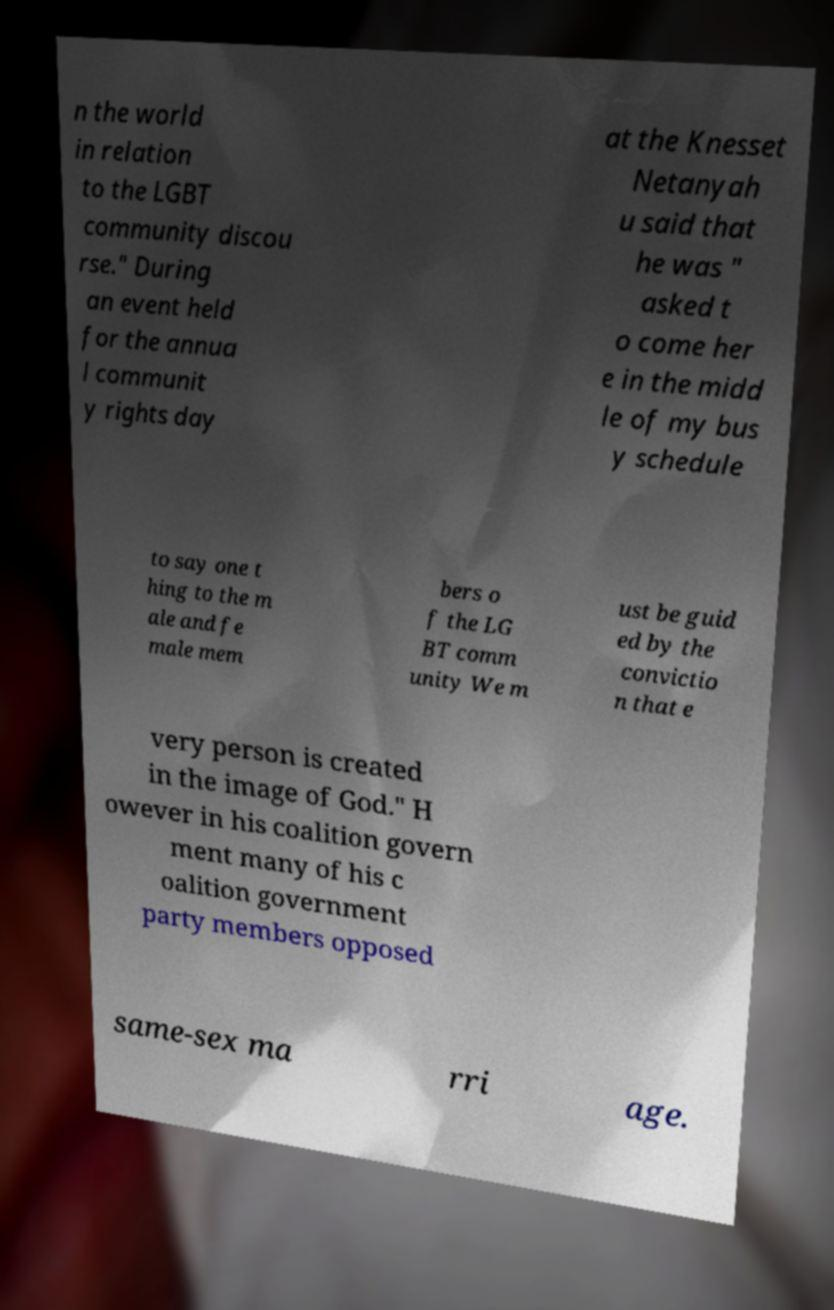Can you accurately transcribe the text from the provided image for me? n the world in relation to the LGBT community discou rse." During an event held for the annua l communit y rights day at the Knesset Netanyah u said that he was " asked t o come her e in the midd le of my bus y schedule to say one t hing to the m ale and fe male mem bers o f the LG BT comm unity We m ust be guid ed by the convictio n that e very person is created in the image of God." H owever in his coalition govern ment many of his c oalition government party members opposed same-sex ma rri age. 